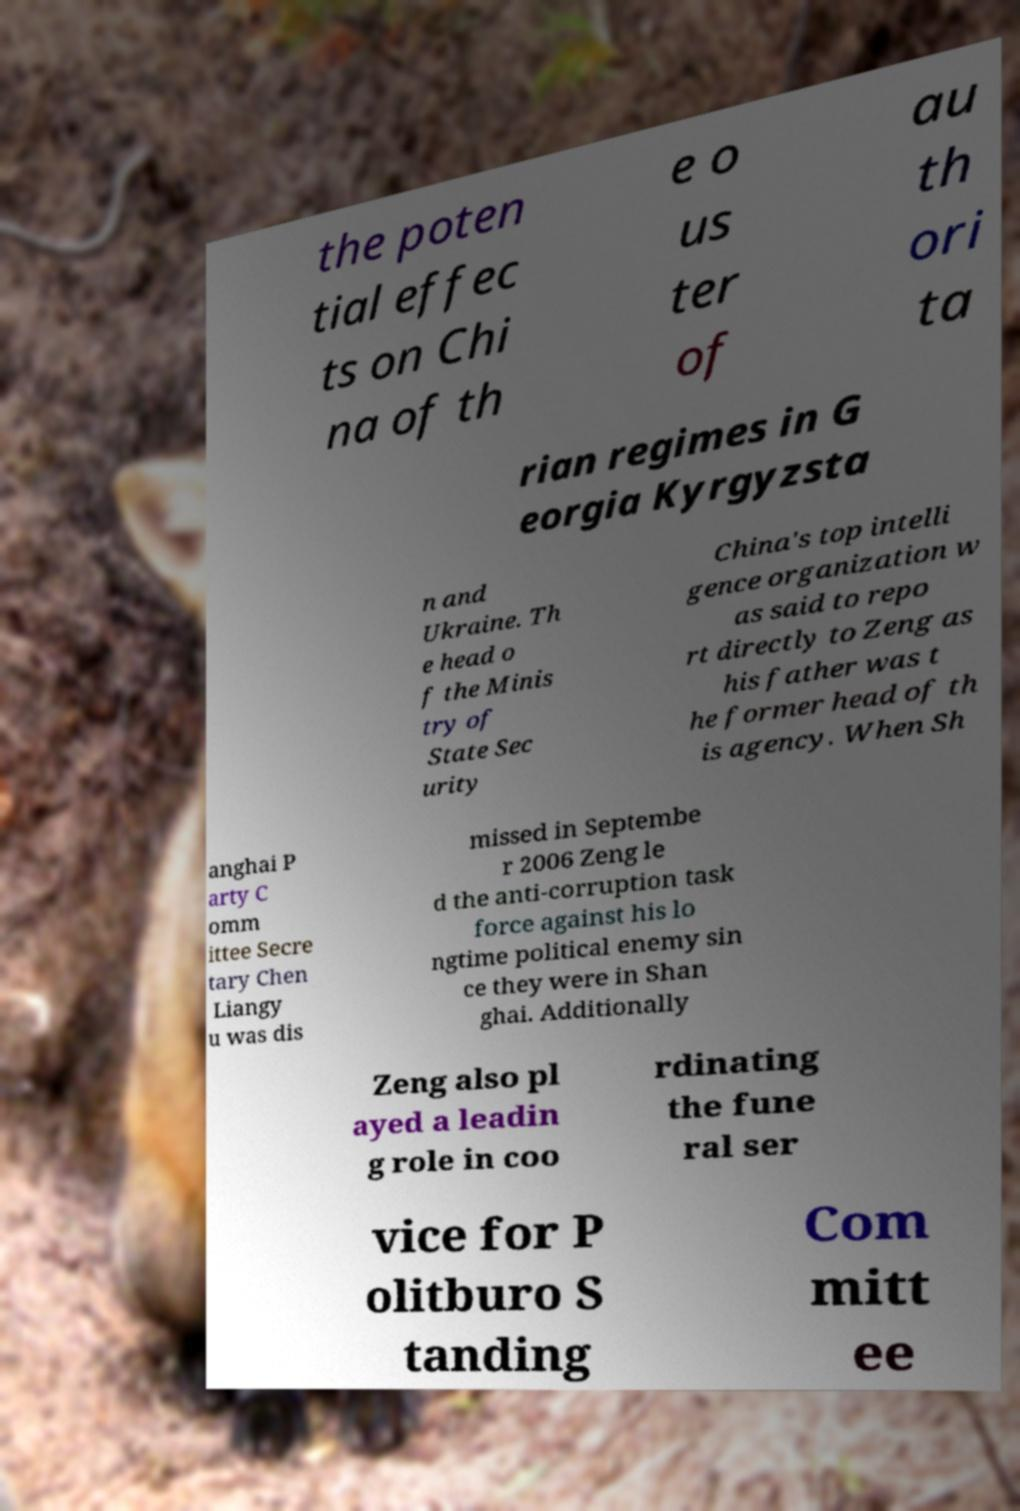Please read and relay the text visible in this image. What does it say? the poten tial effec ts on Chi na of th e o us ter of au th ori ta rian regimes in G eorgia Kyrgyzsta n and Ukraine. Th e head o f the Minis try of State Sec urity China's top intelli gence organization w as said to repo rt directly to Zeng as his father was t he former head of th is agency. When Sh anghai P arty C omm ittee Secre tary Chen Liangy u was dis missed in Septembe r 2006 Zeng le d the anti-corruption task force against his lo ngtime political enemy sin ce they were in Shan ghai. Additionally Zeng also pl ayed a leadin g role in coo rdinating the fune ral ser vice for P olitburo S tanding Com mitt ee 